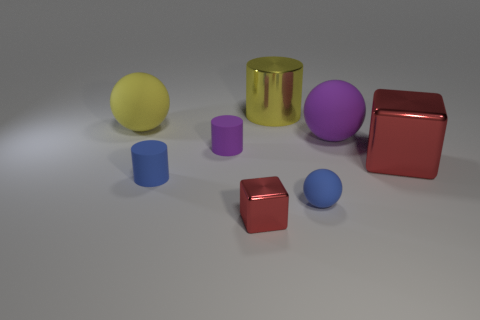Subtract all tiny spheres. How many spheres are left? 2 Add 2 big gray matte cylinders. How many objects exist? 10 Subtract all balls. How many objects are left? 5 Subtract 1 blue spheres. How many objects are left? 7 Subtract all big yellow rubber cylinders. Subtract all red things. How many objects are left? 6 Add 3 shiny things. How many shiny things are left? 6 Add 3 big cylinders. How many big cylinders exist? 4 